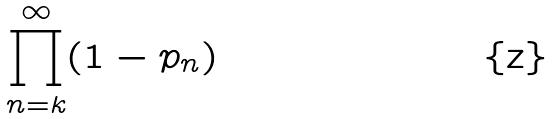Convert formula to latex. <formula><loc_0><loc_0><loc_500><loc_500>\prod _ { n = k } ^ { \infty } ( 1 - p _ { n } )</formula> 